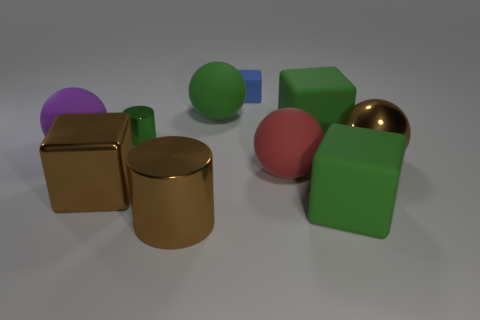Subtract 1 balls. How many balls are left? 3 Subtract all cubes. How many objects are left? 6 Add 1 big brown cylinders. How many big brown cylinders exist? 2 Subtract 0 purple cubes. How many objects are left? 10 Subtract all big gray cylinders. Subtract all large green balls. How many objects are left? 9 Add 2 green cubes. How many green cubes are left? 4 